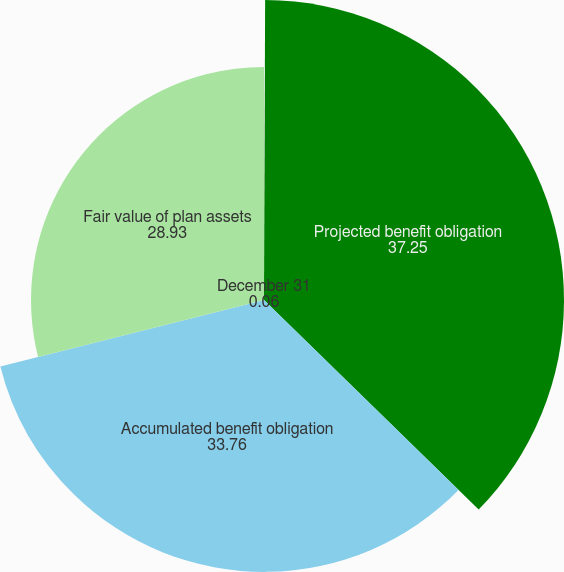Convert chart to OTSL. <chart><loc_0><loc_0><loc_500><loc_500><pie_chart><fcel>December 31<fcel>Projected benefit obligation<fcel>Accumulated benefit obligation<fcel>Fair value of plan assets<nl><fcel>0.06%<fcel>37.25%<fcel>33.76%<fcel>28.93%<nl></chart> 